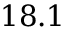Convert formula to latex. <formula><loc_0><loc_0><loc_500><loc_500>1 8 . 1</formula> 